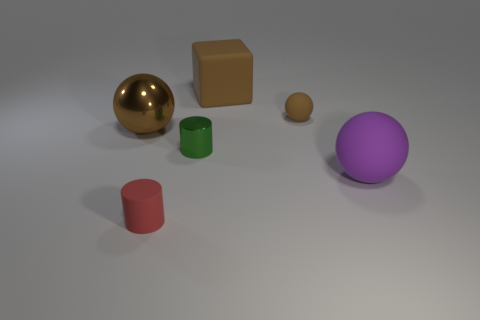Add 4 tiny brown metallic cylinders. How many objects exist? 10 Subtract all cylinders. How many objects are left? 4 Subtract 0 green cubes. How many objects are left? 6 Subtract all large blue rubber things. Subtract all red cylinders. How many objects are left? 5 Add 6 brown cubes. How many brown cubes are left? 7 Add 6 tiny brown rubber spheres. How many tiny brown rubber spheres exist? 7 